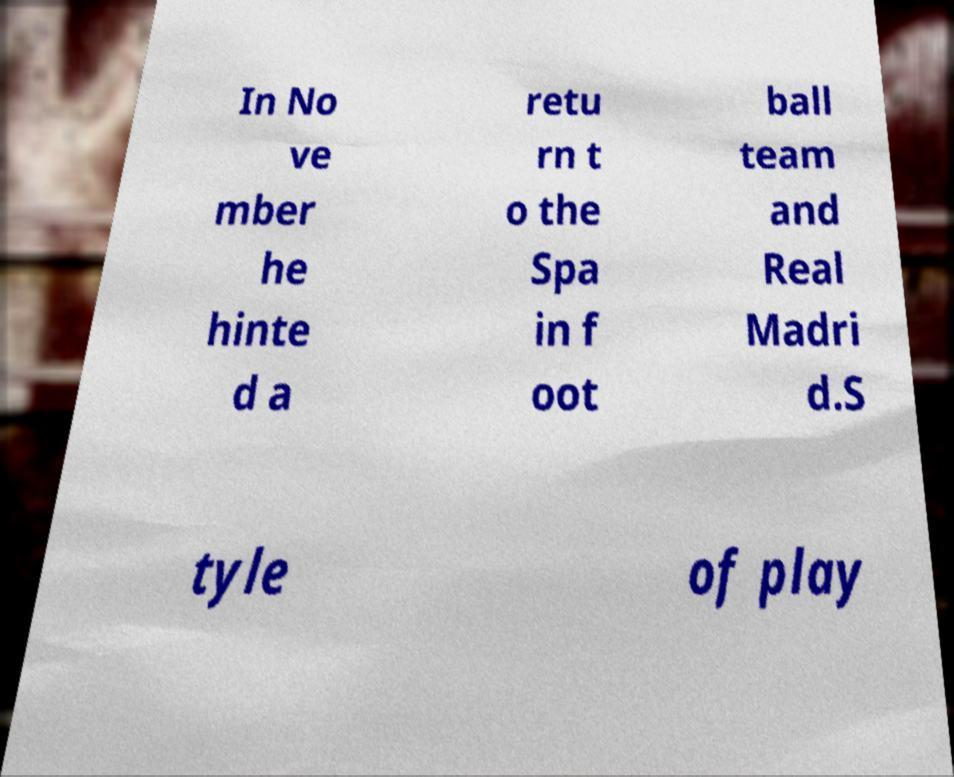For documentation purposes, I need the text within this image transcribed. Could you provide that? In No ve mber he hinte d a retu rn t o the Spa in f oot ball team and Real Madri d.S tyle of play 